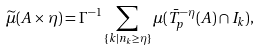<formula> <loc_0><loc_0><loc_500><loc_500>\widetilde { \mu } ( A \times \eta ) = \Gamma ^ { - 1 } \sum _ { \{ k | n _ { k } \geq \eta \} } \mu ( \bar { T } ^ { - \eta } _ { p } ( A ) \cap I _ { k } ) ,</formula> 